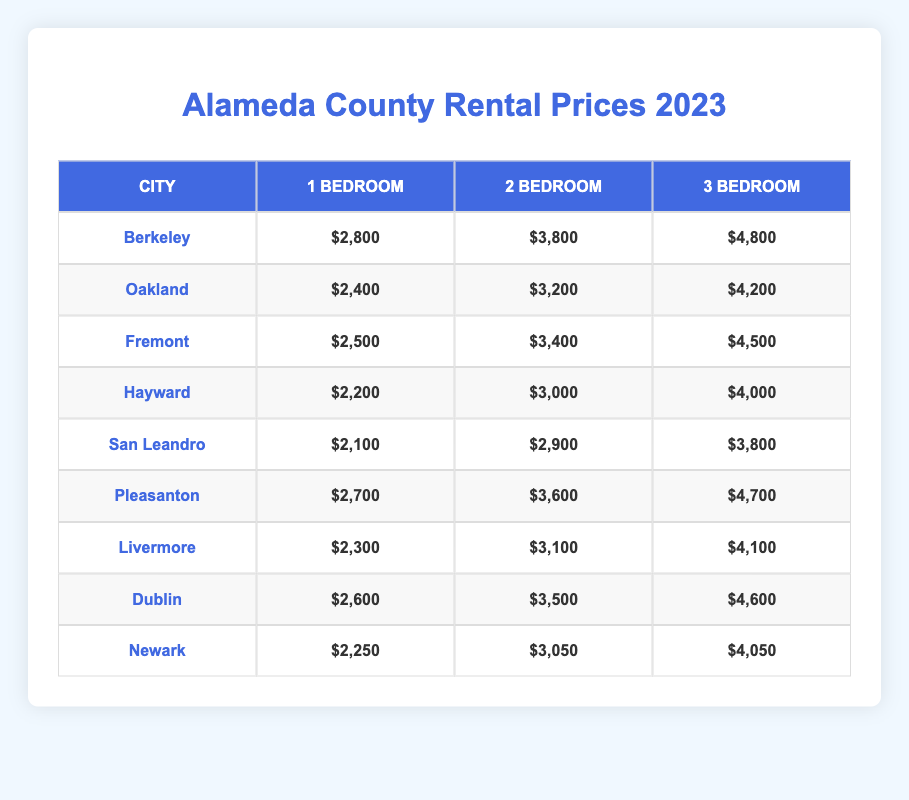What's the rental price of a 1-bedroom apartment in San Leandro? According to the table, the rental price for a 1-bedroom apartment in San Leandro is listed as $2,100.
Answer: $2,100 Which city has the highest rental price for a 3-bedroom apartment? From the table, Berkeley has the highest rental price for a 3-bedroom apartment at $4,800.
Answer: Berkeley What is the average rental price for a 2-bedroom apartment across all cities? To find the average, sum the 2-bedroom prices: (3,800 + 3,200 + 3,400 + 3,000 + 2,900 + 3,600 + 3,100 + 3,500 + 3,050) = 29,600. Then divide by the number of cities (9): 29,600/9 = $3,288.89 (rounded to $3,289).
Answer: $3,289 Is the 1-bedroom rental price in Fremont higher than in Hayward? The 1-bedroom rental price in Fremont is $2,500, while in Hayward it is $2,200. Since $2,500 is greater than $2,200, the statement is true.
Answer: Yes Which city has the lowest combined rental price for a 2-bedroom and 3-bedroom apartment? For combined rental prices: San Leandro (2,900 + 3,800 = 6,700), Hayward (3,000 + 4,000 = 7,000), Newark (3,050 + 4,050 = 7,100), and so on. The lowest combination is San Leandro at $6,700.
Answer: San Leandro What is the difference in rental price between a 1-bedroom in Livermore and a 3-bedroom in Newark? The rental price for a 1-bedroom in Livermore is $2,300 and for a 3-bedroom in Newark is $4,050. The difference is $4,050 - $2,300 = $1,750.
Answer: $1,750 Does Pleasanton have a higher rental price for a 2-bedroom apartment compared to Fremont? The 2-bedroom rental price in Pleasanton is $3,600 and in Fremont is $3,400. Since $3,600 is greater than $3,400, the statement is true.
Answer: Yes What is the median rental price for a 1-bedroom apartment across all cities? To find the median, first list the 1-bedroom prices in ascending order: 2,100 (San Leandro), 2,200 (Hayward), 2,250 (Newark), 2,300 (Livermore), 2,500 (Fremont), 2,600 (Dublin), 2,700 (Pleasanton), 2,800 (Berkeley), 2,400 (Oakland). The median is the middle value: the 5th and 6th values are $2,500 and $2,600, so the median is ($2,500 + $2,600)/2 = $2,550.
Answer: $2,550 Which city offers the lowest price for a 3-bedroom apartment? A look at the table shows that San Leandro has the lowest 3-bedroom rental price at $3,800.
Answer: San Leandro 